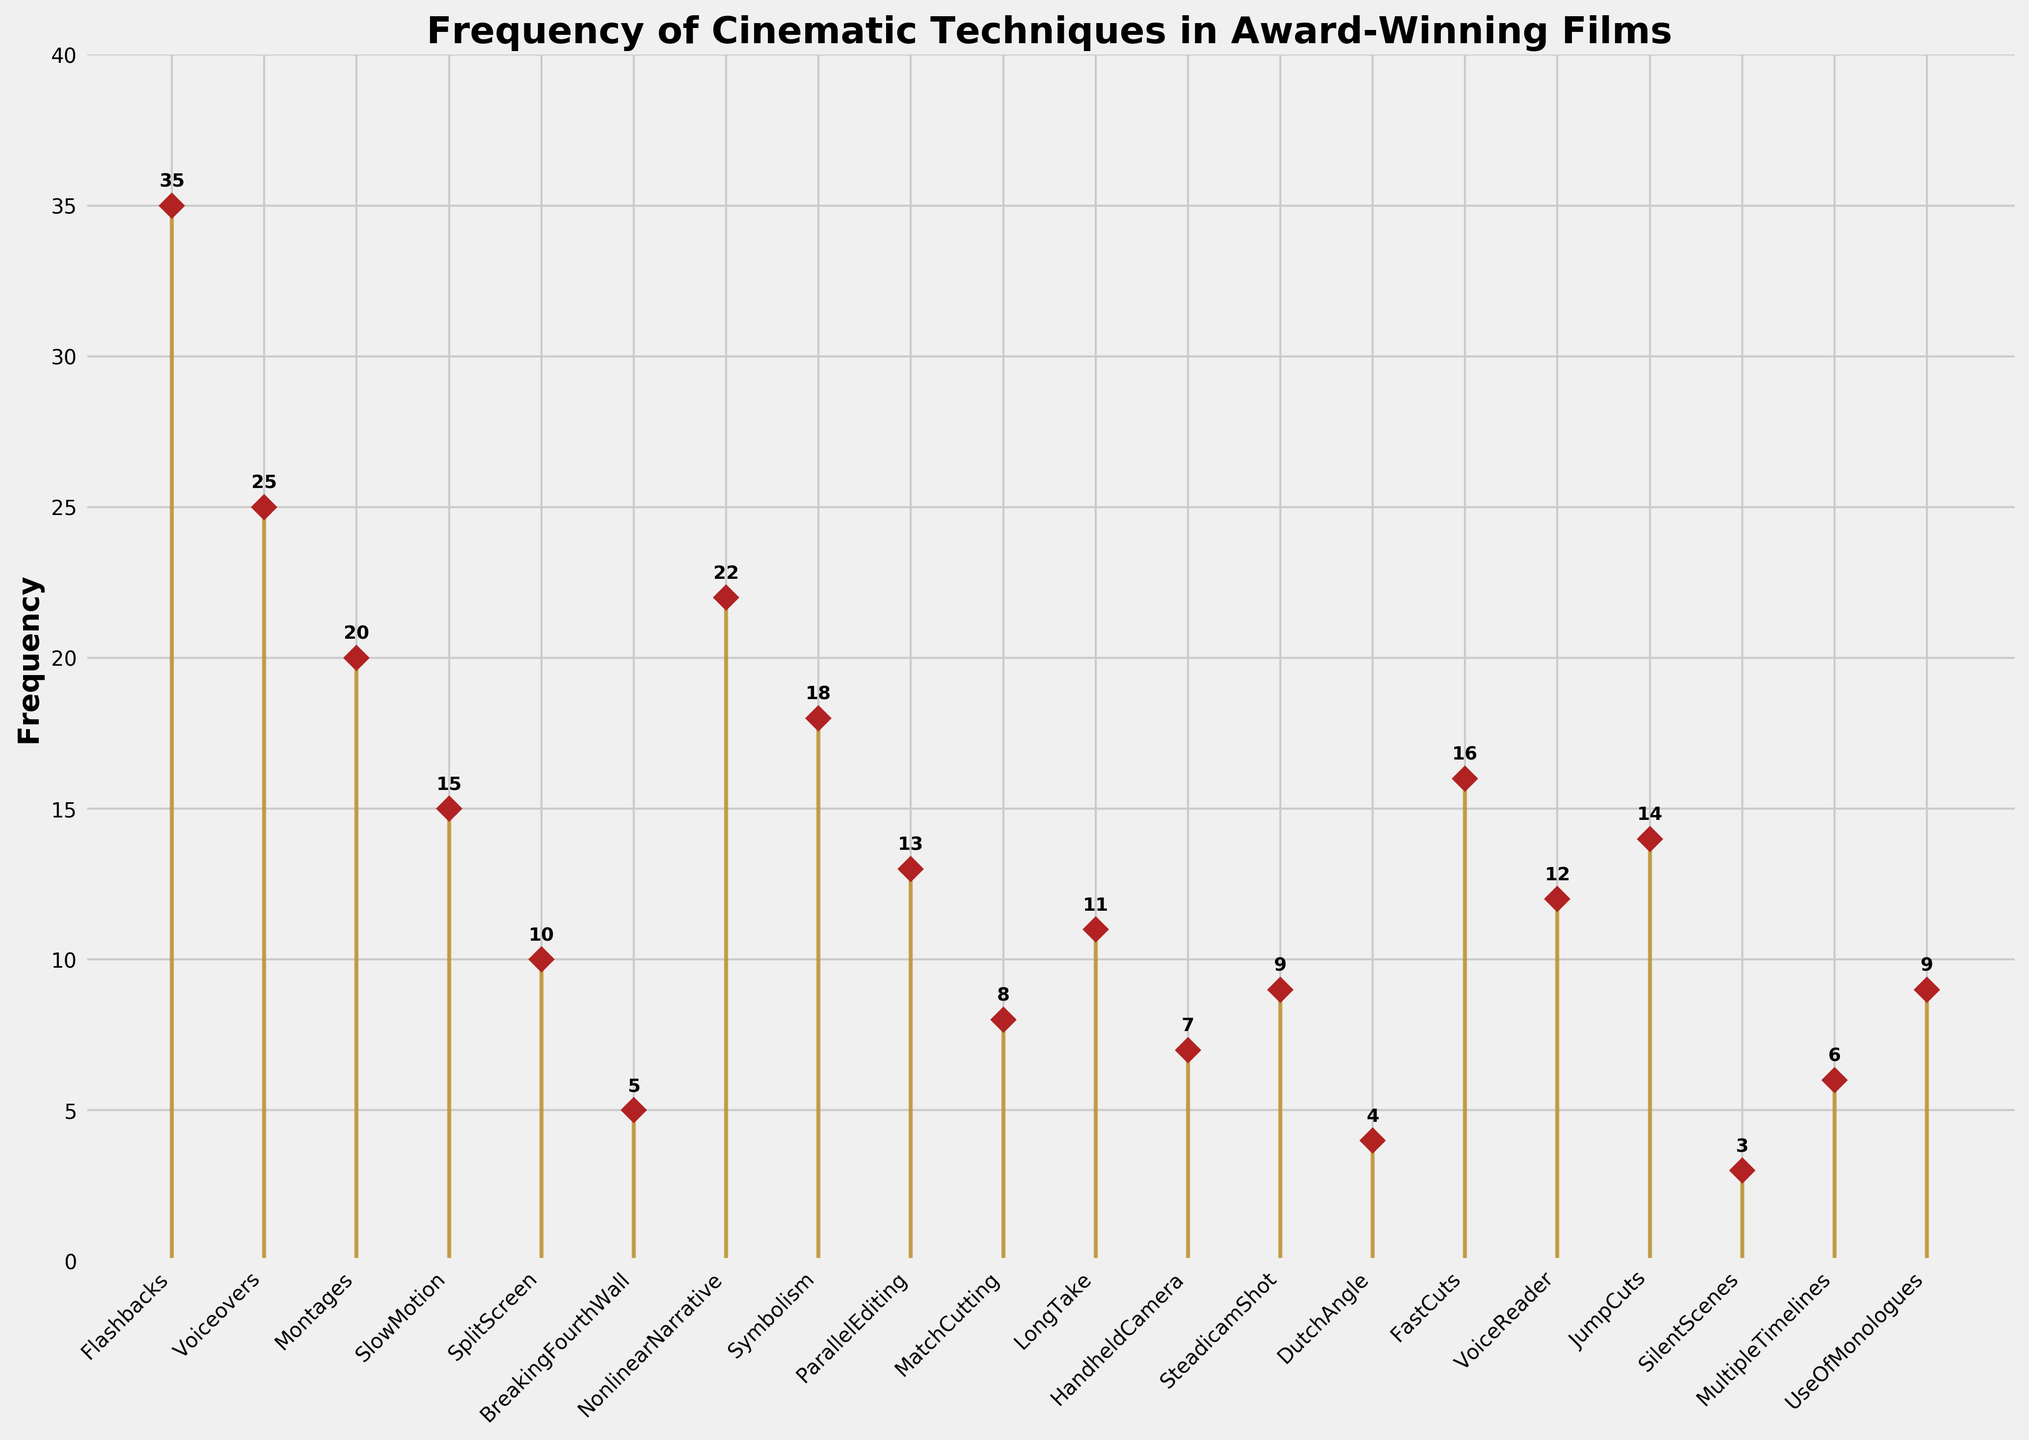Which cinematic technique appears most frequently? By observing the highest point on the stem plot, we can identify the cinematic technique with the highest frequency value. In this case, 'Flashbacks' has the highest frequency of 35.
Answer: Flashbacks What is the least frequent cinematic technique shown? The smallest value on the stem plot indicates the least frequent cinematic technique. Here, 'SilentScenes' has the lowest frequency with a value of 3.
Answer: SilentScenes What is the total frequency of 'Montages' and 'Voiceovers'? To find the total frequency, add the frequency values of 'Montages' (20) and 'Voiceovers' (25). So, the total is 20 + 25 = 45.
Answer: 45 How many cinematic techniques have a frequency of at least 20? By examining the stem plot, count the techniques with a frequency equal to or greater than 20. The techniques are 'Flashbacks', 'Voiceovers', 'Montages', and 'NonlinearNarrative'. Thus, there are 4 techniques.
Answer: 4 Which technique has a higher frequency, 'HandheldCamera' or 'JumpCuts'? Compare the frequencies of 'HandheldCamera' (7) and 'JumpCuts' (14). 'JumpCuts' has a higher frequency than 'HandheldCamera'.
Answer: JumpCuts What is the combined frequency of the top three techniques? The top three techniques by frequency are 'Flashbacks' (35), 'Voiceovers' (25), and 'NonlinearNarrative' (22). Add their frequencies: 35 + 25 + 22 = 82.
Answer: 82 Are there more techniques with a frequency value above 10 or below 10? Count the number of techniques with frequencies above 10 ('Flashbacks', 'Voiceovers', 'Montages', 'SlowMotion', 'NonlinearNarrative', 'Symbolism', 'ParallelEditing', 'FastCuts', 'VoiceReader', 'JumpCuts', 'UseOfMonologues', 'SplitScreen', 'SteadicamShot', 'MatchCutting', 'HandheldCamera', 'MultipleTimelines', 'BreakingFourthWall', 'SilentScenes'). There are 11 techniques above 10 and 9 below 10.
Answer: Above What is the frequency range of 'DutchAngle' to 'Symbolism'? The range is calculated by subtracting the smallest frequency ('DutchAngle' = 4) from the largest frequency ('Symbolism' = 18) within this range: 18 - 4 = 14.
Answer: 14 How does the frequency of 'SlowMotion' compare to the average frequency of all techniques? First, sum all frequencies and divide by the number of techniques. The total frequency is 248, and there are 20 techniques. The average frequency is 248 / 20 = 12.4. 'SlowMotion' has a frequency of 15, which is higher than the average frequency.
Answer: Higher 